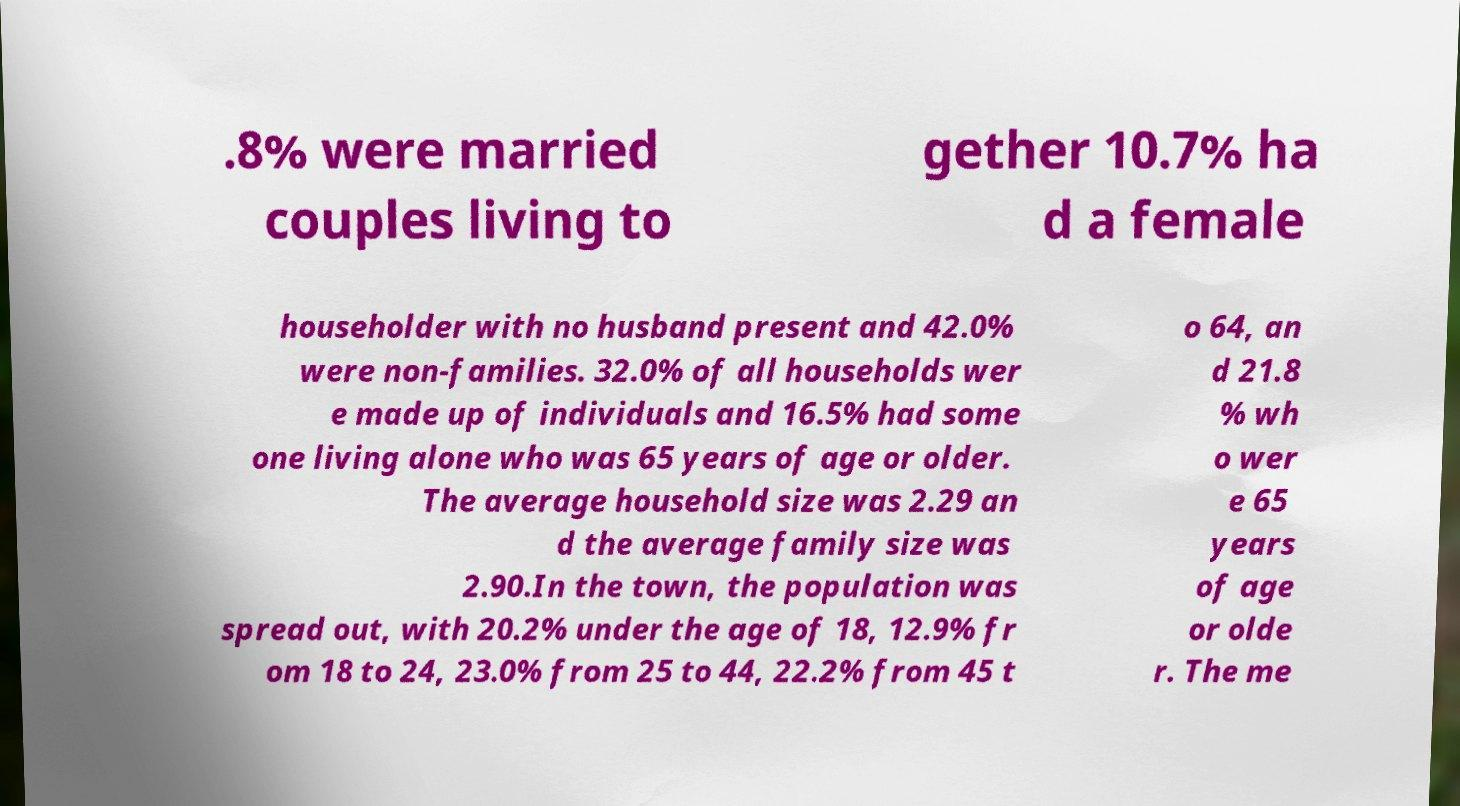Can you accurately transcribe the text from the provided image for me? .8% were married couples living to gether 10.7% ha d a female householder with no husband present and 42.0% were non-families. 32.0% of all households wer e made up of individuals and 16.5% had some one living alone who was 65 years of age or older. The average household size was 2.29 an d the average family size was 2.90.In the town, the population was spread out, with 20.2% under the age of 18, 12.9% fr om 18 to 24, 23.0% from 25 to 44, 22.2% from 45 t o 64, an d 21.8 % wh o wer e 65 years of age or olde r. The me 